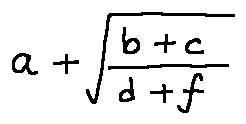<formula> <loc_0><loc_0><loc_500><loc_500>a + \sqrt { \frac { b + c } { d + f } }</formula> 